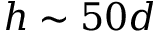<formula> <loc_0><loc_0><loc_500><loc_500>h \sim 5 0 d</formula> 